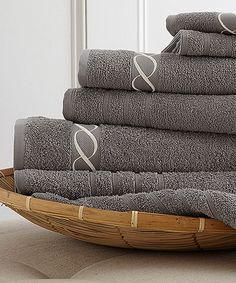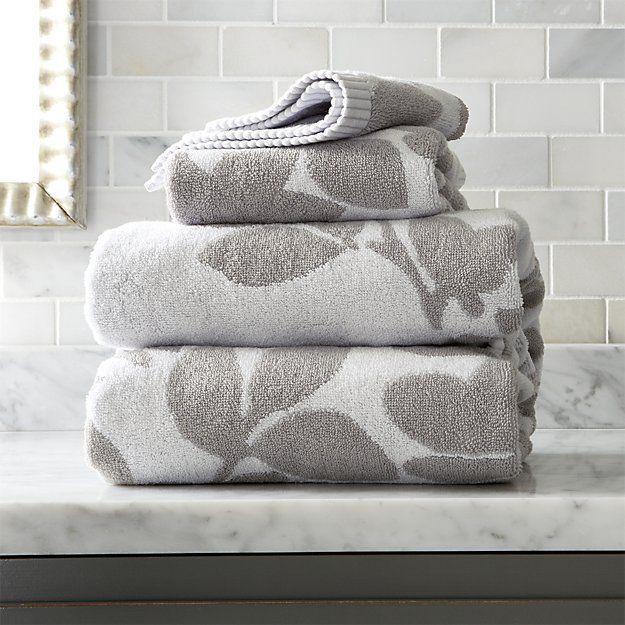The first image is the image on the left, the second image is the image on the right. For the images displayed, is the sentence "The towels in the image on the left are gray." factually correct? Answer yes or no. Yes. The first image is the image on the left, the second image is the image on the right. Evaluate the accuracy of this statement regarding the images: "The leftmost images feature a stack of grey towels.". Is it true? Answer yes or no. Yes. 